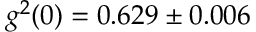Convert formula to latex. <formula><loc_0><loc_0><loc_500><loc_500>g ^ { 2 } ( 0 ) = 0 . 6 2 9 \pm 0 . 0 0 6</formula> 